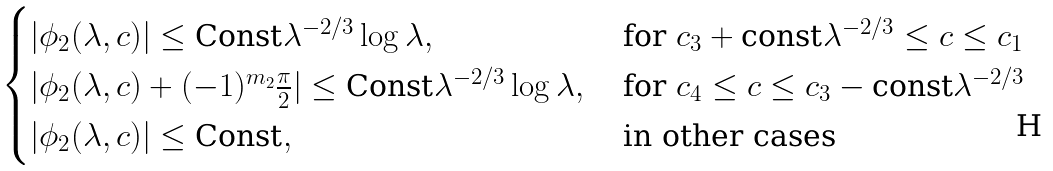<formula> <loc_0><loc_0><loc_500><loc_500>\begin{cases} | \phi _ { 2 } ( \lambda , c ) | \leq \text {Const} \lambda ^ { - 2 / 3 } \log \lambda , & \text { for } c _ { 3 } + \text {const} \lambda ^ { - 2 / 3 } \leq c \leq c _ { 1 } \\ | \phi _ { 2 } ( \lambda , c ) + ( - 1 ) ^ { m _ { 2 } } \frac { \pi } { 2 } | \leq \text {Const} \lambda ^ { - 2 / 3 } \log \lambda , & \text { for } c _ { 4 } \leq c \leq c _ { 3 } - \text {const} \lambda ^ { - 2 / 3 } \\ | \phi _ { 2 } ( \lambda , c ) | \leq \text {Const} , & \text { in other cases} \\ \end{cases}</formula> 